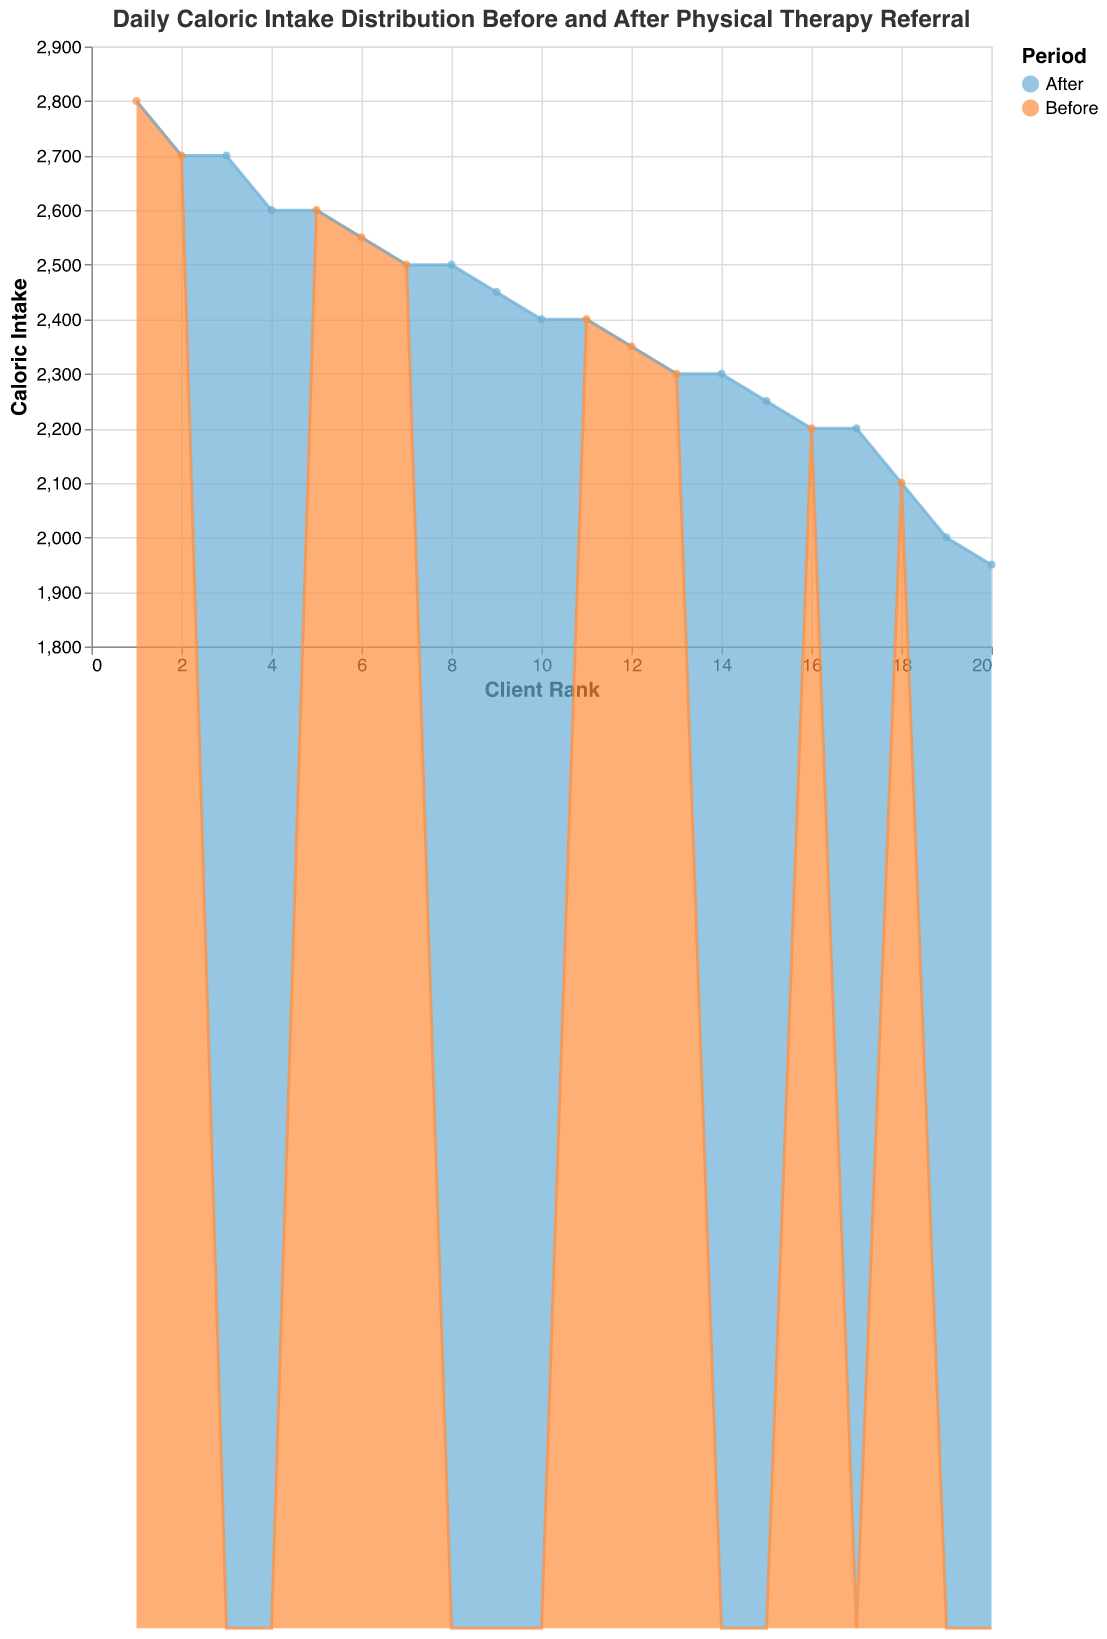What's the title of the chart? The title of the chart is located at the top and provides a summary of what the chart is about. In this case, the title reads "Daily Caloric Intake Distribution Before and After Physical Therapy Referral."
Answer: Daily Caloric Intake Distribution Before and After Physical Therapy Referral What do the colors represent in the chart? The colors in the chart distinguish between the two periods: Before referral is represented in blue and After referral in orange.
Answer: Blue for Before, Orange for After How many clients' data are plotted in the chart? Each client is assigned a rank on the x-axis, and there are 10 rank positions, indicating that data from 10 clients are plotted in the chart.
Answer: 10 Which client had the highest caloric intake before referral? To find this, look for the highest point in the blue area of the chart. Michael Green had the highest caloric intake before referral at 2800 calories.
Answer: Michael Green Which client had the lowest caloric intake after referral? The lowest point in the orange area indicates the client with the lowest caloric intake after referral, which is Amanda White with 1950 calories.
Answer: Amanda White What is the difference in caloric intake for John Smith before and after referral? John Smith’s caloric intake before referral was 2500 calories, and after referral, it was 2400 calories. The difference is 2500 - 2400 = 100 calories.
Answer: 100 calories What is the average caloric intake of clients before referral? Sum the caloric intake of all clients before referral (2500 + 2200 + 2700 + 2300 + 2800 + 2100 + 2600 + 2400 + 2550 + 2350) = 24500 calories, and divide by the number of clients (10). The average is 24500 / 10 = 2450 calories.
Answer: 2450 calories Who had the least change in caloric intake after referral? Find the client with the smallest difference between their before and after intake. Sarah Brown shows the least change, with only a 50-calorie reduction (2300 - 2250).
Answer: Sarah Brown What is the median caloric intake after referral for these clients? List the caloric intakes after referral in ascending order (1950, 2000, 2200, 2250, 2300, 2400, 2450, 2500, 2600, 2700). The median is the average of the 5th and 6th values: (2300 + 2400) / 2 = 2350 calories.
Answer: 2350 calories 